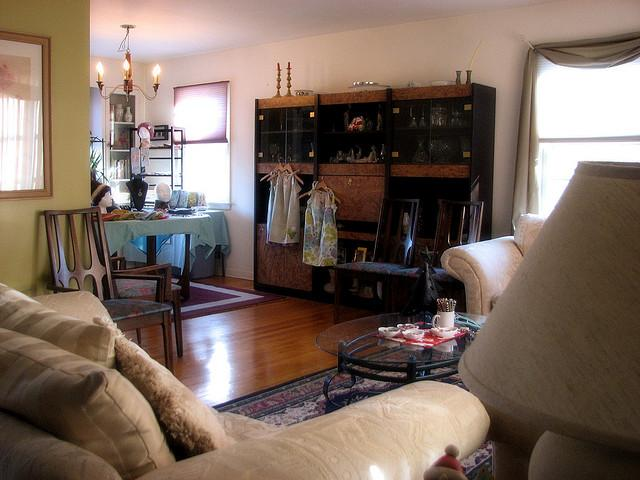Why are the clothes on hangers? Please explain your reasoning. airing out. The clothes are being dried. 